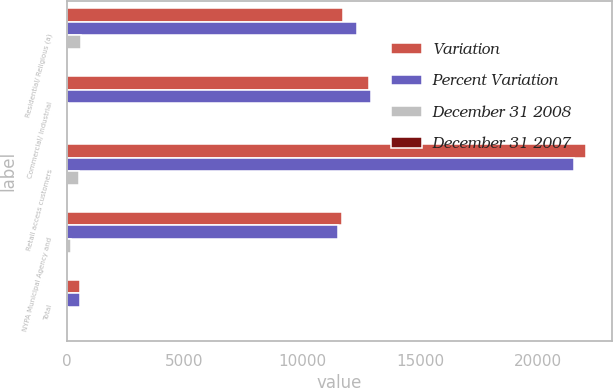Convert chart. <chart><loc_0><loc_0><loc_500><loc_500><stacked_bar_chart><ecel><fcel>Residential/ Religious (a)<fcel>Commercial/ Industrial<fcel>Retail access customers<fcel>NYPA Municipal Agency and<fcel>Total<nl><fcel>Variation<fcel>11720<fcel>12852<fcel>22047<fcel>11704<fcel>553.5<nl><fcel>Percent Variation<fcel>12312<fcel>12918<fcel>21532<fcel>11499<fcel>553.5<nl><fcel>December 31 2008<fcel>592<fcel>66<fcel>515<fcel>205<fcel>62<nl><fcel>December 31 2007<fcel>4.8<fcel>0.5<fcel>2.4<fcel>1.8<fcel>0.1<nl></chart> 